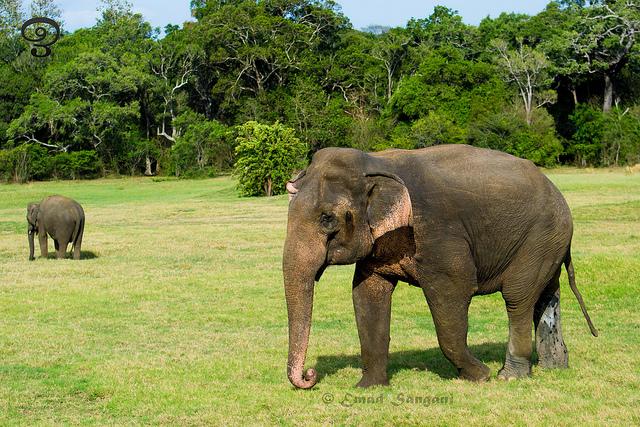Which one is smaller?
Write a very short answer. Left. Is it daytime?
Be succinct. Yes. Is there a dog in the picture?
Be succinct. No. Are there trees in the image?
Write a very short answer. Yes. 